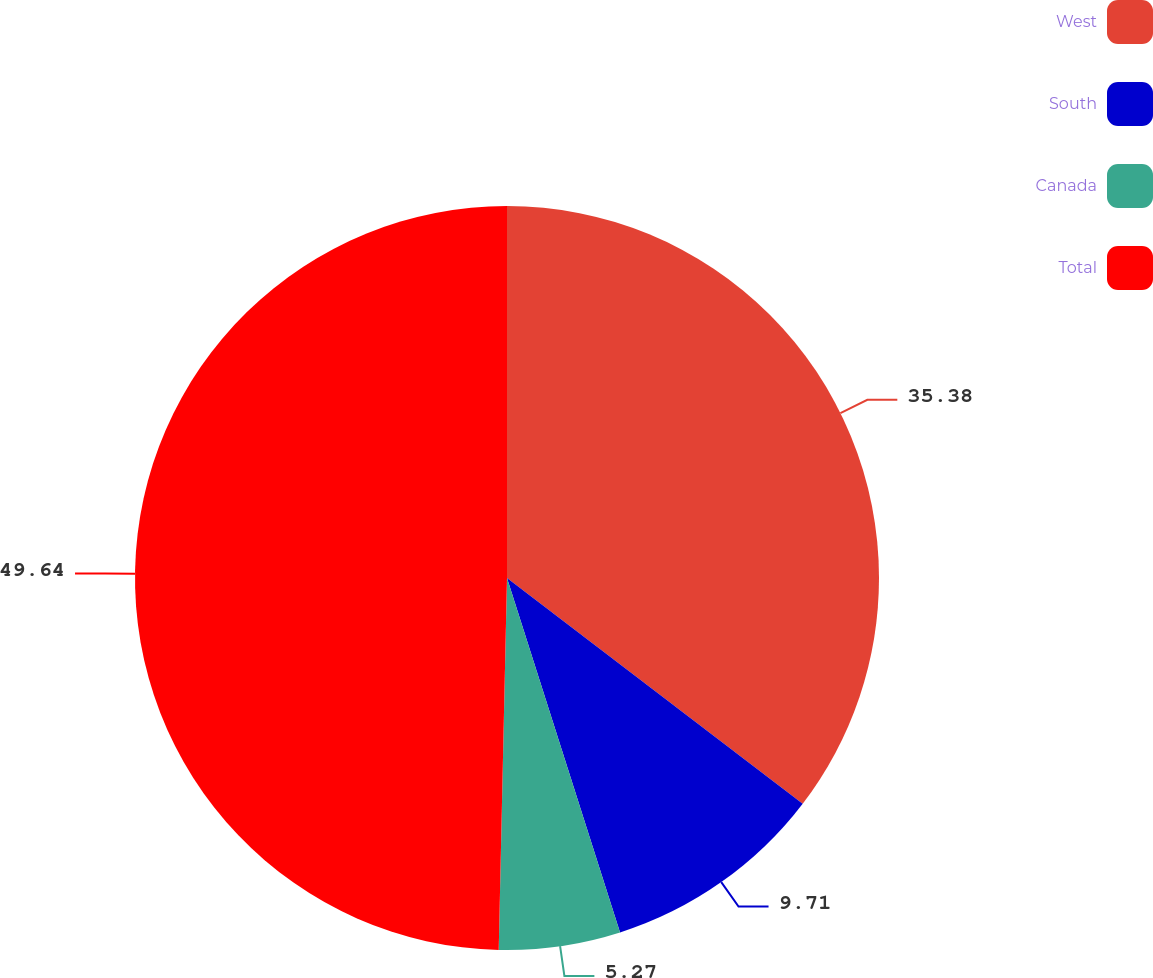Convert chart. <chart><loc_0><loc_0><loc_500><loc_500><pie_chart><fcel>West<fcel>South<fcel>Canada<fcel>Total<nl><fcel>35.38%<fcel>9.71%<fcel>5.27%<fcel>49.65%<nl></chart> 